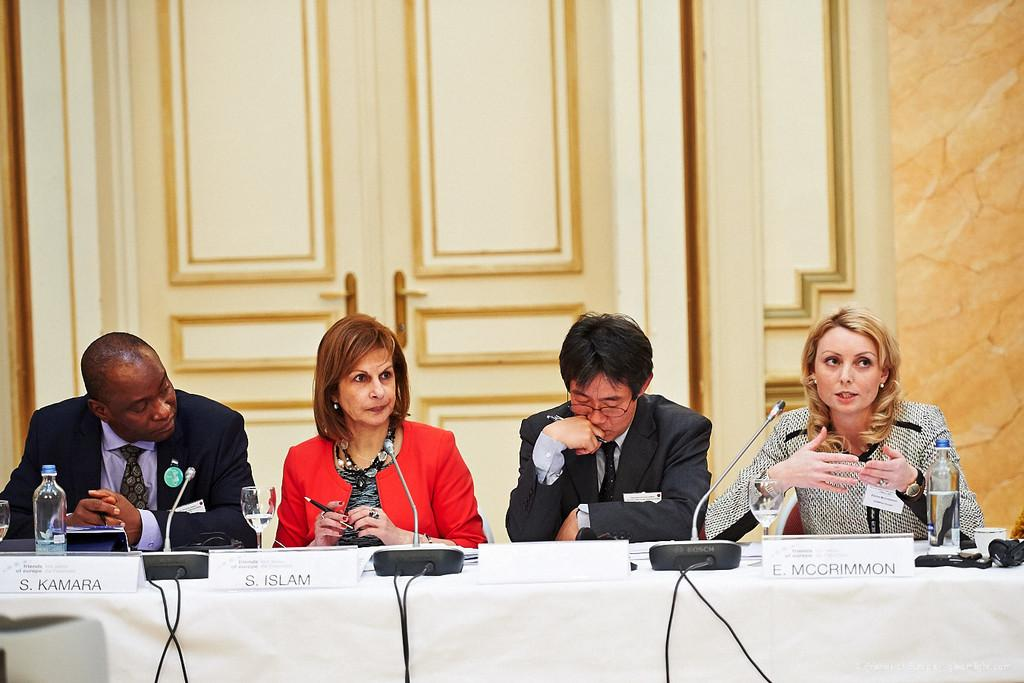What are the people in the image doing? The people in the image are sitting on chairs. Where are the chairs located in relation to the table? The chairs are near a table. What object can be seen in the image besides the chairs and table? There is a bottle in the image. What can be seen in the background of the image? There is a door in the background of the image. What is the reason behind the number of chairs in the image? The number of chairs in the image is not mentioned in the provided facts, so it is impossible to determine the reason behind it. 